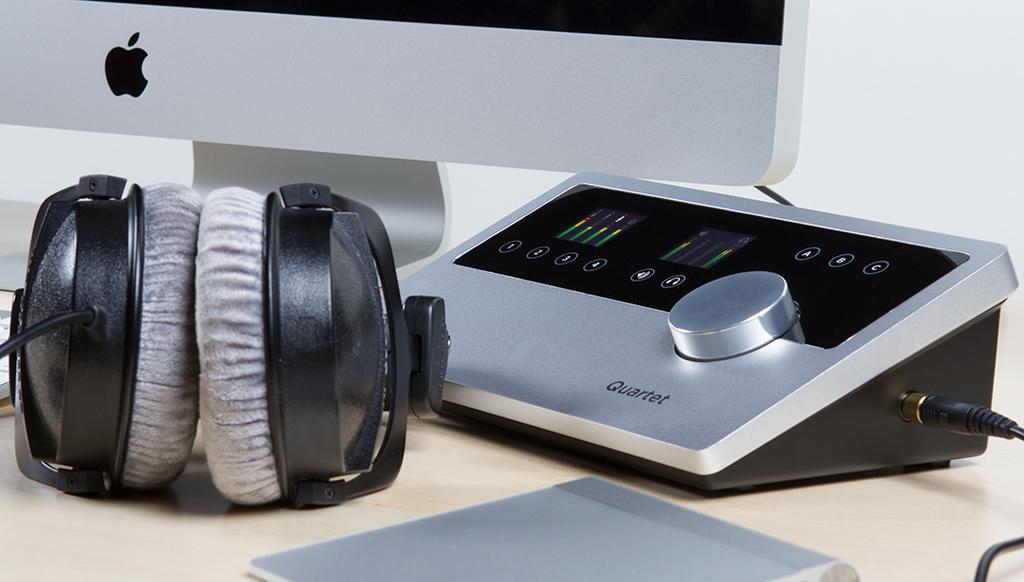What piece of furniture is present in the image? The image contains a table. What electronic device is on the table? There is a headset and a device on the table. What is the color of the background in the image? The background of the image is white. Can you describe the monitor in the image? The monitor is on the table, but it is truncated. How many legs can be seen on the table in the image? The image does not show the legs of the table, so it is impossible to determine the number of legs from the information provided. 